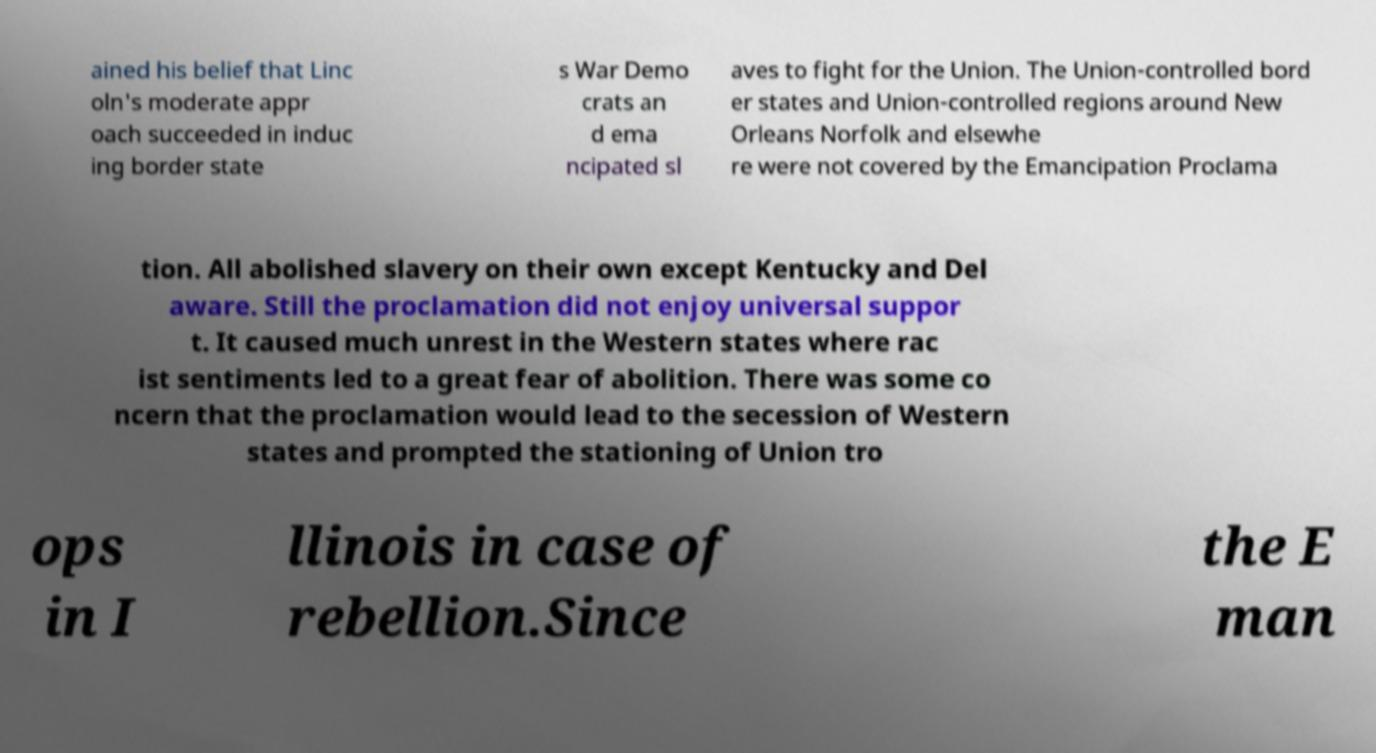There's text embedded in this image that I need extracted. Can you transcribe it verbatim? ained his belief that Linc oln's moderate appr oach succeeded in induc ing border state s War Demo crats an d ema ncipated sl aves to fight for the Union. The Union-controlled bord er states and Union-controlled regions around New Orleans Norfolk and elsewhe re were not covered by the Emancipation Proclama tion. All abolished slavery on their own except Kentucky and Del aware. Still the proclamation did not enjoy universal suppor t. It caused much unrest in the Western states where rac ist sentiments led to a great fear of abolition. There was some co ncern that the proclamation would lead to the secession of Western states and prompted the stationing of Union tro ops in I llinois in case of rebellion.Since the E man 